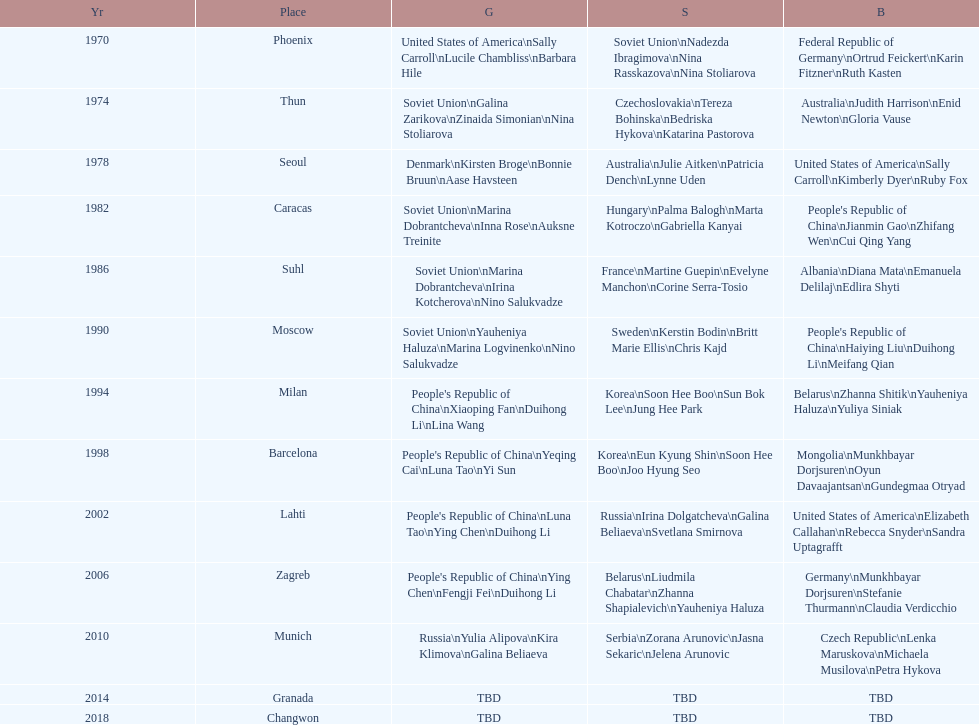Which country is listed the most under the silver column? Korea. Write the full table. {'header': ['Yr', 'Place', 'G', 'S', 'B'], 'rows': [['1970', 'Phoenix', 'United States of America\\nSally Carroll\\nLucile Chambliss\\nBarbara Hile', 'Soviet Union\\nNadezda Ibragimova\\nNina Rasskazova\\nNina Stoliarova', 'Federal Republic of Germany\\nOrtrud Feickert\\nKarin Fitzner\\nRuth Kasten'], ['1974', 'Thun', 'Soviet Union\\nGalina Zarikova\\nZinaida Simonian\\nNina Stoliarova', 'Czechoslovakia\\nTereza Bohinska\\nBedriska Hykova\\nKatarina Pastorova', 'Australia\\nJudith Harrison\\nEnid Newton\\nGloria Vause'], ['1978', 'Seoul', 'Denmark\\nKirsten Broge\\nBonnie Bruun\\nAase Havsteen', 'Australia\\nJulie Aitken\\nPatricia Dench\\nLynne Uden', 'United States of America\\nSally Carroll\\nKimberly Dyer\\nRuby Fox'], ['1982', 'Caracas', 'Soviet Union\\nMarina Dobrantcheva\\nInna Rose\\nAuksne Treinite', 'Hungary\\nPalma Balogh\\nMarta Kotroczo\\nGabriella Kanyai', "People's Republic of China\\nJianmin Gao\\nZhifang Wen\\nCui Qing Yang"], ['1986', 'Suhl', 'Soviet Union\\nMarina Dobrantcheva\\nIrina Kotcherova\\nNino Salukvadze', 'France\\nMartine Guepin\\nEvelyne Manchon\\nCorine Serra-Tosio', 'Albania\\nDiana Mata\\nEmanuela Delilaj\\nEdlira Shyti'], ['1990', 'Moscow', 'Soviet Union\\nYauheniya Haluza\\nMarina Logvinenko\\nNino Salukvadze', 'Sweden\\nKerstin Bodin\\nBritt Marie Ellis\\nChris Kajd', "People's Republic of China\\nHaiying Liu\\nDuihong Li\\nMeifang Qian"], ['1994', 'Milan', "People's Republic of China\\nXiaoping Fan\\nDuihong Li\\nLina Wang", 'Korea\\nSoon Hee Boo\\nSun Bok Lee\\nJung Hee Park', 'Belarus\\nZhanna Shitik\\nYauheniya Haluza\\nYuliya Siniak'], ['1998', 'Barcelona', "People's Republic of China\\nYeqing Cai\\nLuna Tao\\nYi Sun", 'Korea\\nEun Kyung Shin\\nSoon Hee Boo\\nJoo Hyung Seo', 'Mongolia\\nMunkhbayar Dorjsuren\\nOyun Davaajantsan\\nGundegmaa Otryad'], ['2002', 'Lahti', "People's Republic of China\\nLuna Tao\\nYing Chen\\nDuihong Li", 'Russia\\nIrina Dolgatcheva\\nGalina Beliaeva\\nSvetlana Smirnova', 'United States of America\\nElizabeth Callahan\\nRebecca Snyder\\nSandra Uptagrafft'], ['2006', 'Zagreb', "People's Republic of China\\nYing Chen\\nFengji Fei\\nDuihong Li", 'Belarus\\nLiudmila Chabatar\\nZhanna Shapialevich\\nYauheniya Haluza', 'Germany\\nMunkhbayar Dorjsuren\\nStefanie Thurmann\\nClaudia Verdicchio'], ['2010', 'Munich', 'Russia\\nYulia Alipova\\nKira Klimova\\nGalina Beliaeva', 'Serbia\\nZorana Arunovic\\nJasna Sekaric\\nJelena Arunovic', 'Czech Republic\\nLenka Maruskova\\nMichaela Musilova\\nPetra Hykova'], ['2014', 'Granada', 'TBD', 'TBD', 'TBD'], ['2018', 'Changwon', 'TBD', 'TBD', 'TBD']]} 